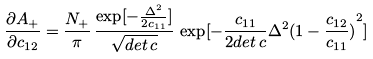<formula> <loc_0><loc_0><loc_500><loc_500>\frac { \partial A _ { + } } { \partial c _ { 1 2 } } = \frac { { N _ { + } } } { \pi } \, \frac { \exp [ - \frac { { \Delta } ^ { 2 } } { 2 c _ { 1 1 } } ] } { \sqrt { d e t \, c } } \, \exp [ - \frac { c _ { 1 1 } } { 2 d e t \, c } { \Delta } ^ { 2 } { ( 1 - \frac { c _ { 1 2 } } { c _ { 1 1 } } ) } ^ { 2 } ]</formula> 